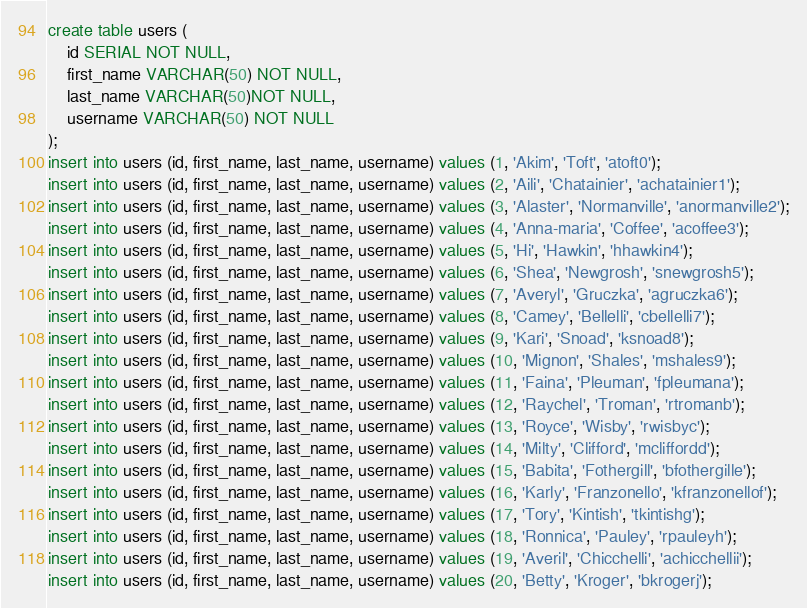<code> <loc_0><loc_0><loc_500><loc_500><_SQL_>create table users (
	id SERIAL NOT NULL,
	first_name VARCHAR(50) NOT NULL,
	last_name VARCHAR(50)NOT NULL,
	username VARCHAR(50) NOT NULL
);
insert into users (id, first_name, last_name, username) values (1, 'Akim', 'Toft', 'atoft0');
insert into users (id, first_name, last_name, username) values (2, 'Aili', 'Chatainier', 'achatainier1');
insert into users (id, first_name, last_name, username) values (3, 'Alaster', 'Normanville', 'anormanville2');
insert into users (id, first_name, last_name, username) values (4, 'Anna-maria', 'Coffee', 'acoffee3');
insert into users (id, first_name, last_name, username) values (5, 'Hi', 'Hawkin', 'hhawkin4');
insert into users (id, first_name, last_name, username) values (6, 'Shea', 'Newgrosh', 'snewgrosh5');
insert into users (id, first_name, last_name, username) values (7, 'Averyl', 'Gruczka', 'agruczka6');
insert into users (id, first_name, last_name, username) values (8, 'Camey', 'Bellelli', 'cbellelli7');
insert into users (id, first_name, last_name, username) values (9, 'Kari', 'Snoad', 'ksnoad8');
insert into users (id, first_name, last_name, username) values (10, 'Mignon', 'Shales', 'mshales9');
insert into users (id, first_name, last_name, username) values (11, 'Faina', 'Pleuman', 'fpleumana');
insert into users (id, first_name, last_name, username) values (12, 'Raychel', 'Troman', 'rtromanb');
insert into users (id, first_name, last_name, username) values (13, 'Royce', 'Wisby', 'rwisbyc');
insert into users (id, first_name, last_name, username) values (14, 'Milty', 'Clifford', 'mcliffordd');
insert into users (id, first_name, last_name, username) values (15, 'Babita', 'Fothergill', 'bfothergille');
insert into users (id, first_name, last_name, username) values (16, 'Karly', 'Franzonello', 'kfranzonellof');
insert into users (id, first_name, last_name, username) values (17, 'Tory', 'Kintish', 'tkintishg');
insert into users (id, first_name, last_name, username) values (18, 'Ronnica', 'Pauley', 'rpauleyh');
insert into users (id, first_name, last_name, username) values (19, 'Averil', 'Chicchelli', 'achicchellii');
insert into users (id, first_name, last_name, username) values (20, 'Betty', 'Kroger', 'bkrogerj');
</code> 